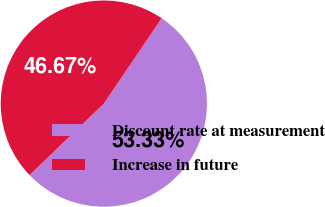Convert chart. <chart><loc_0><loc_0><loc_500><loc_500><pie_chart><fcel>Discount rate at measurement<fcel>Increase in future<nl><fcel>53.33%<fcel>46.67%<nl></chart> 